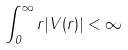Convert formula to latex. <formula><loc_0><loc_0><loc_500><loc_500>\int _ { 0 } ^ { \infty } r | V ( r ) | < \infty</formula> 